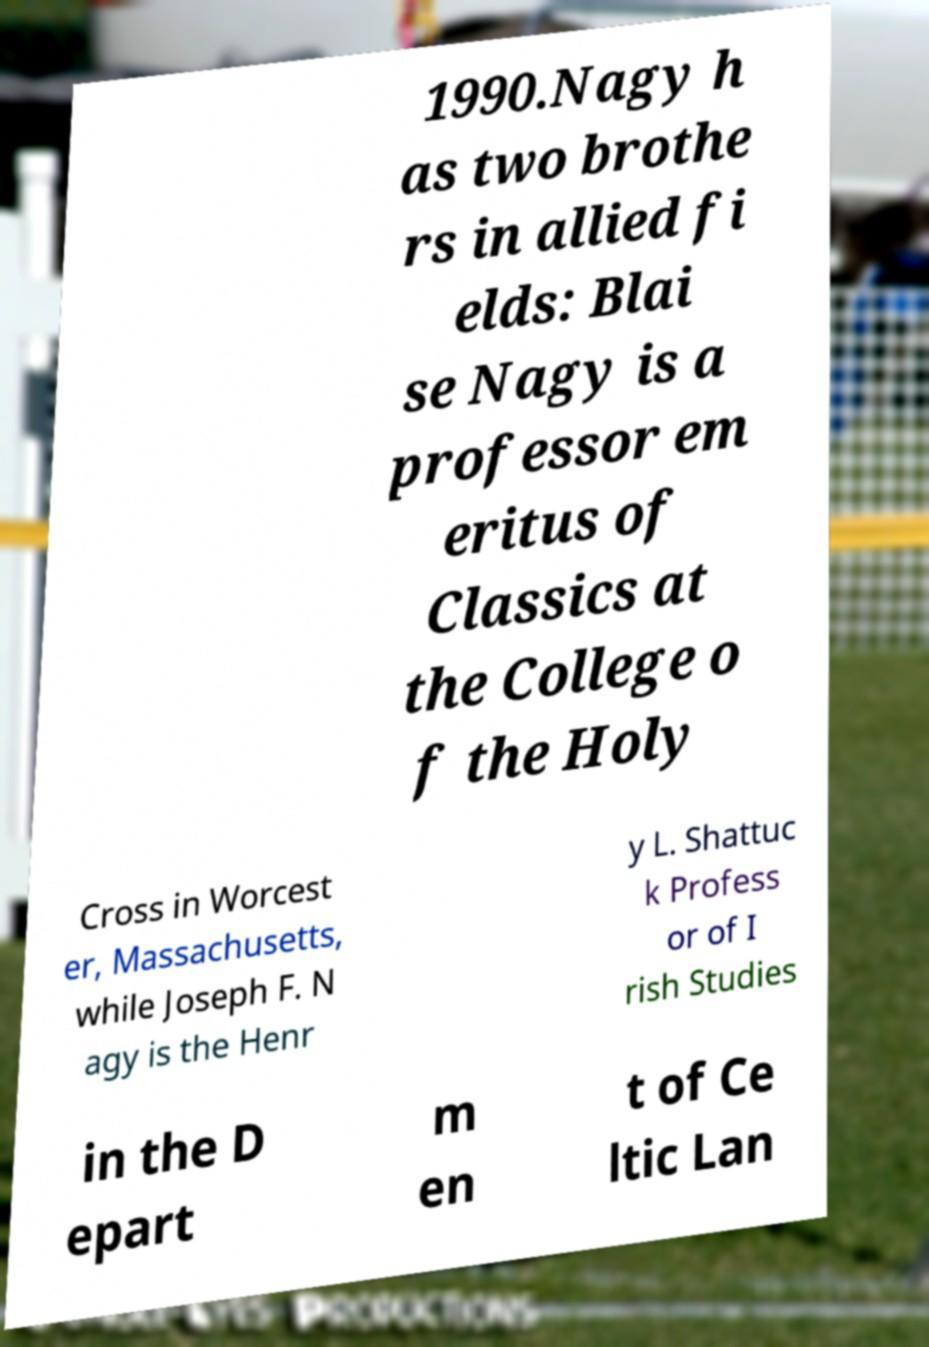Can you accurately transcribe the text from the provided image for me? 1990.Nagy h as two brothe rs in allied fi elds: Blai se Nagy is a professor em eritus of Classics at the College o f the Holy Cross in Worcest er, Massachusetts, while Joseph F. N agy is the Henr y L. Shattuc k Profess or of I rish Studies in the D epart m en t of Ce ltic Lan 